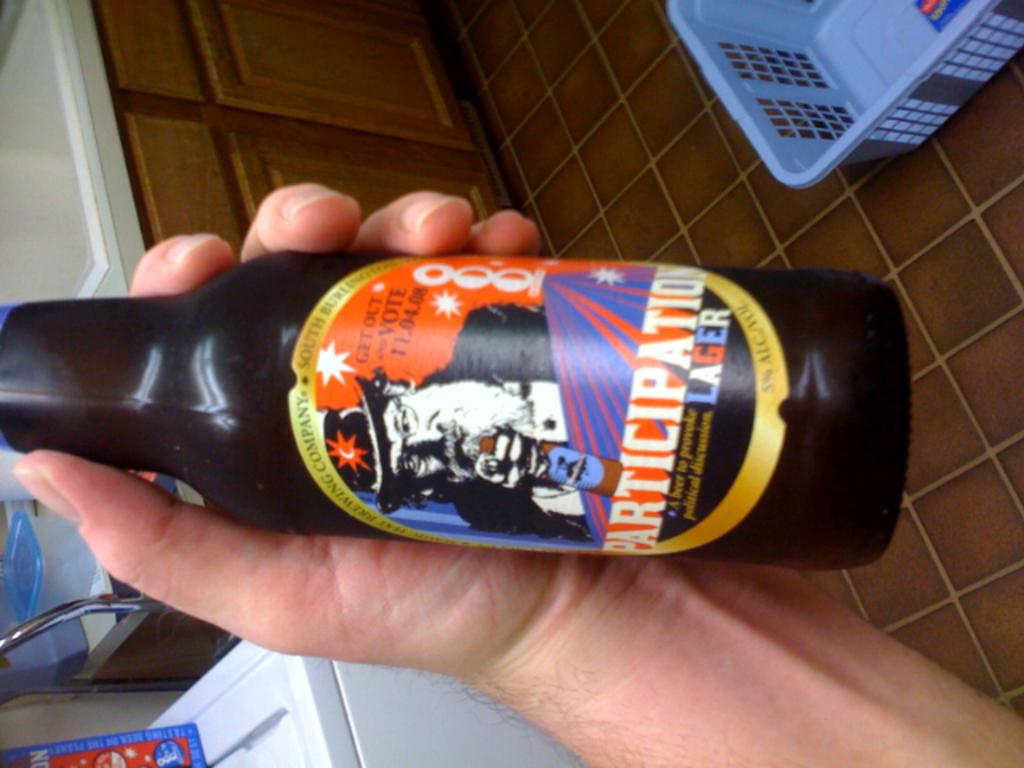What is being held by the hand in the image? The hand is holding a bottle. What can be seen on the bottle? There is text written on the bottle. What type of mint can be seen growing near the hand in the image? There is no mint present in the image. What knowledge can be gained from the text written on the bottle in the image? The text on the bottle cannot be read in the image, so it is not possible to determine what knowledge can be gained from it. 